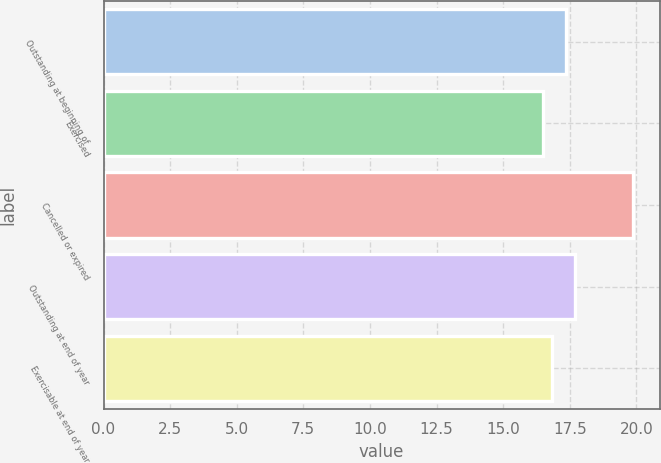Convert chart. <chart><loc_0><loc_0><loc_500><loc_500><bar_chart><fcel>Outstanding at beginning of<fcel>Exercised<fcel>Cancelled or expired<fcel>Outstanding at end of year<fcel>Exercisable at end of year<nl><fcel>17.37<fcel>16.49<fcel>19.89<fcel>17.71<fcel>16.83<nl></chart> 